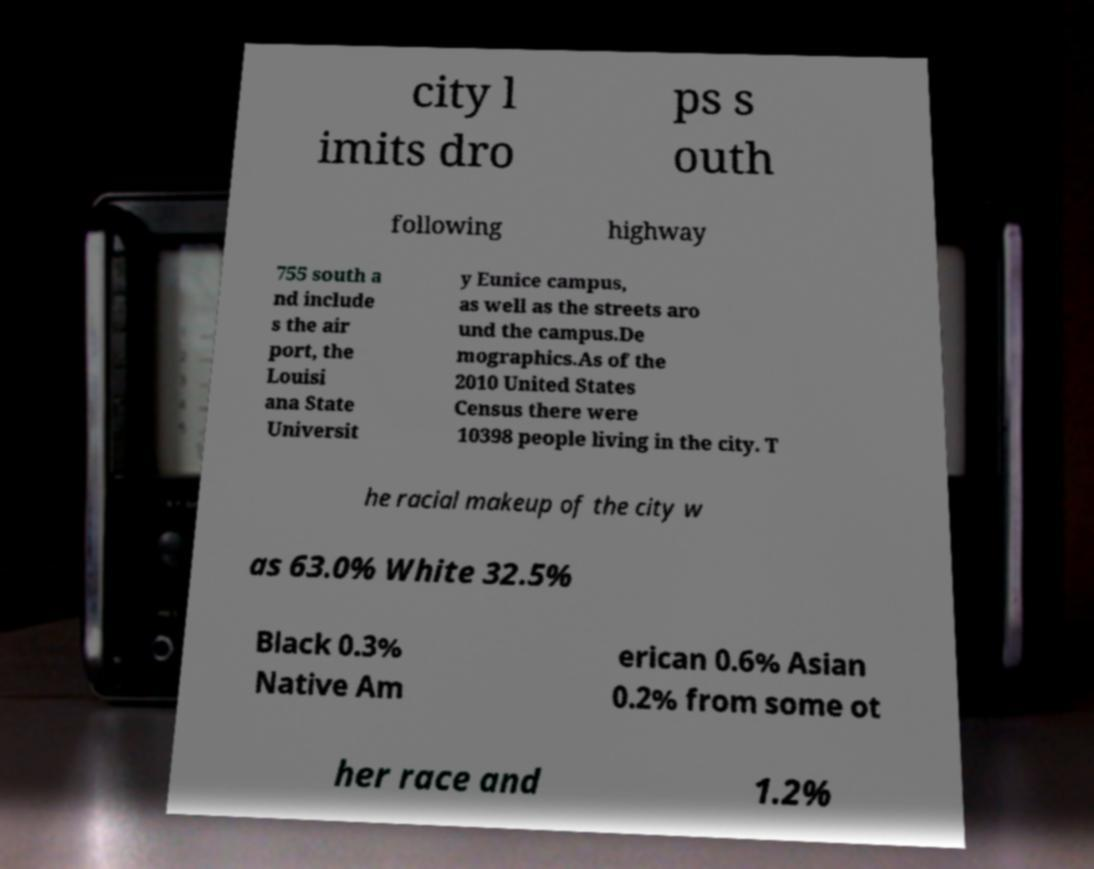Could you assist in decoding the text presented in this image and type it out clearly? city l imits dro ps s outh following highway 755 south a nd include s the air port, the Louisi ana State Universit y Eunice campus, as well as the streets aro und the campus.De mographics.As of the 2010 United States Census there were 10398 people living in the city. T he racial makeup of the city w as 63.0% White 32.5% Black 0.3% Native Am erican 0.6% Asian 0.2% from some ot her race and 1.2% 